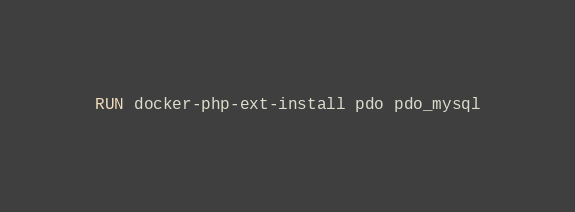Convert code to text. <code><loc_0><loc_0><loc_500><loc_500><_Dockerfile_>
RUN docker-php-ext-install pdo pdo_mysql</code> 